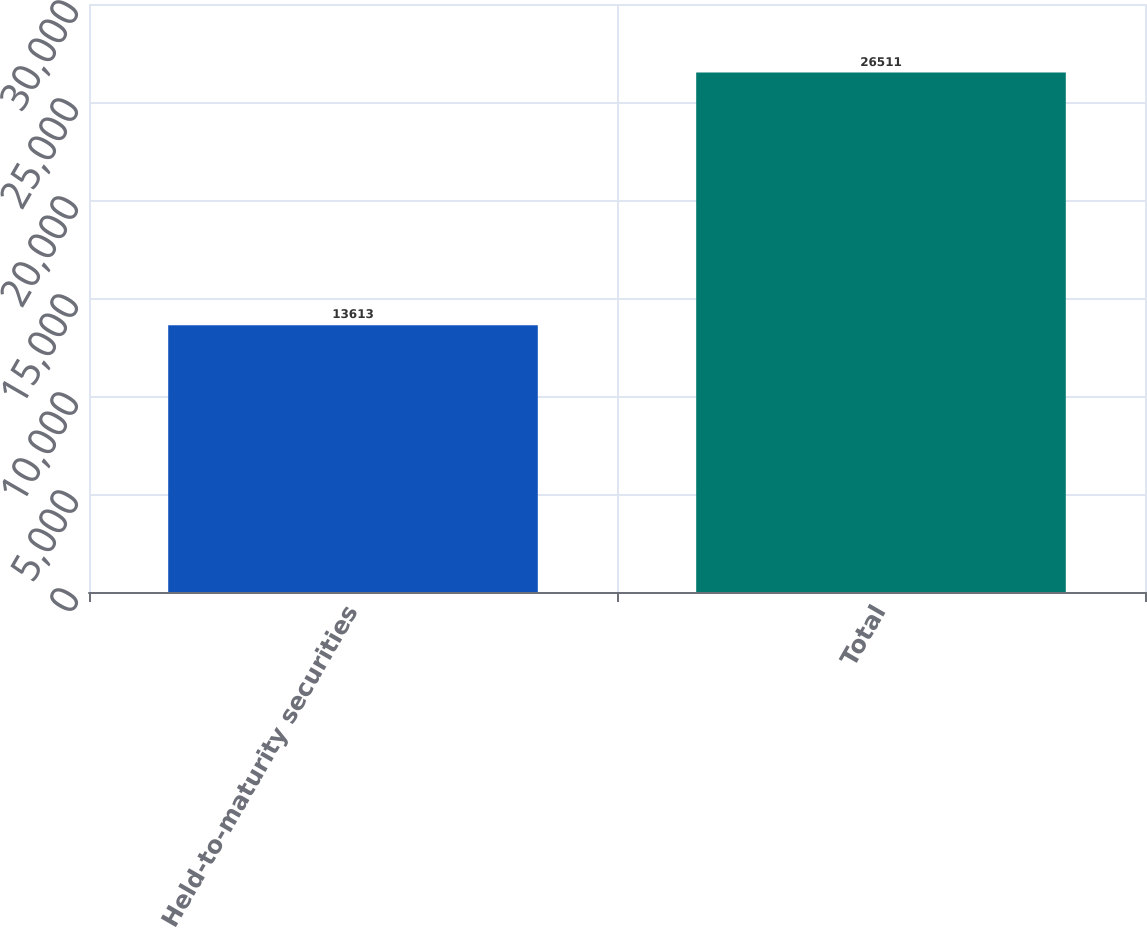Convert chart. <chart><loc_0><loc_0><loc_500><loc_500><bar_chart><fcel>Held-to-maturity securities<fcel>Total<nl><fcel>13613<fcel>26511<nl></chart> 